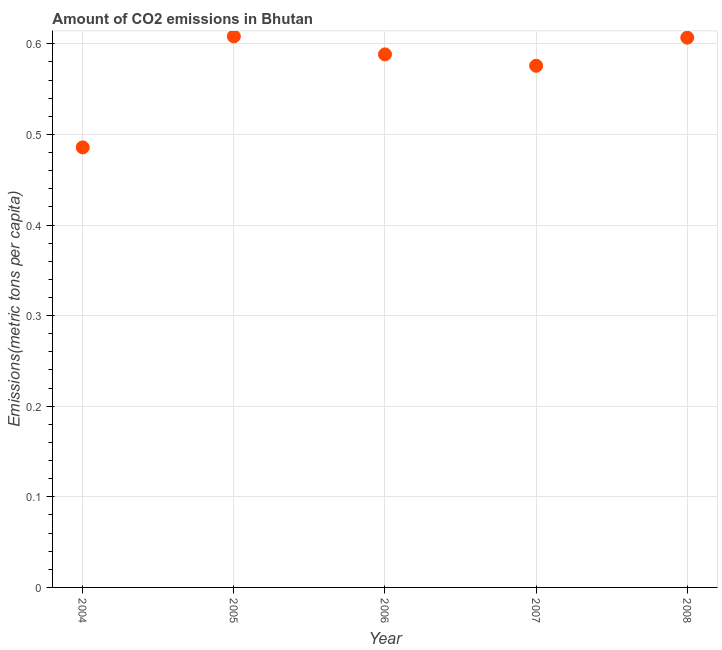What is the amount of co2 emissions in 2005?
Your response must be concise. 0.61. Across all years, what is the maximum amount of co2 emissions?
Your answer should be very brief. 0.61. Across all years, what is the minimum amount of co2 emissions?
Your answer should be compact. 0.49. What is the sum of the amount of co2 emissions?
Provide a short and direct response. 2.86. What is the difference between the amount of co2 emissions in 2004 and 2006?
Offer a very short reply. -0.1. What is the average amount of co2 emissions per year?
Offer a very short reply. 0.57. What is the median amount of co2 emissions?
Make the answer very short. 0.59. In how many years, is the amount of co2 emissions greater than 0.44 metric tons per capita?
Your answer should be compact. 5. What is the ratio of the amount of co2 emissions in 2005 to that in 2006?
Offer a terse response. 1.03. Is the amount of co2 emissions in 2004 less than that in 2008?
Make the answer very short. Yes. What is the difference between the highest and the second highest amount of co2 emissions?
Offer a very short reply. 0. What is the difference between the highest and the lowest amount of co2 emissions?
Offer a terse response. 0.12. In how many years, is the amount of co2 emissions greater than the average amount of co2 emissions taken over all years?
Your response must be concise. 4. Does the amount of co2 emissions monotonically increase over the years?
Provide a succinct answer. No. How many dotlines are there?
Ensure brevity in your answer.  1. What is the difference between two consecutive major ticks on the Y-axis?
Ensure brevity in your answer.  0.1. Are the values on the major ticks of Y-axis written in scientific E-notation?
Make the answer very short. No. Does the graph contain any zero values?
Your answer should be very brief. No. What is the title of the graph?
Ensure brevity in your answer.  Amount of CO2 emissions in Bhutan. What is the label or title of the X-axis?
Ensure brevity in your answer.  Year. What is the label or title of the Y-axis?
Ensure brevity in your answer.  Emissions(metric tons per capita). What is the Emissions(metric tons per capita) in 2004?
Ensure brevity in your answer.  0.49. What is the Emissions(metric tons per capita) in 2005?
Provide a succinct answer. 0.61. What is the Emissions(metric tons per capita) in 2006?
Ensure brevity in your answer.  0.59. What is the Emissions(metric tons per capita) in 2007?
Offer a very short reply. 0.58. What is the Emissions(metric tons per capita) in 2008?
Ensure brevity in your answer.  0.61. What is the difference between the Emissions(metric tons per capita) in 2004 and 2005?
Your answer should be compact. -0.12. What is the difference between the Emissions(metric tons per capita) in 2004 and 2006?
Your answer should be compact. -0.1. What is the difference between the Emissions(metric tons per capita) in 2004 and 2007?
Provide a succinct answer. -0.09. What is the difference between the Emissions(metric tons per capita) in 2004 and 2008?
Give a very brief answer. -0.12. What is the difference between the Emissions(metric tons per capita) in 2005 and 2006?
Your answer should be compact. 0.02. What is the difference between the Emissions(metric tons per capita) in 2005 and 2007?
Give a very brief answer. 0.03. What is the difference between the Emissions(metric tons per capita) in 2005 and 2008?
Your response must be concise. 0. What is the difference between the Emissions(metric tons per capita) in 2006 and 2007?
Ensure brevity in your answer.  0.01. What is the difference between the Emissions(metric tons per capita) in 2006 and 2008?
Your response must be concise. -0.02. What is the difference between the Emissions(metric tons per capita) in 2007 and 2008?
Your answer should be compact. -0.03. What is the ratio of the Emissions(metric tons per capita) in 2004 to that in 2005?
Give a very brief answer. 0.8. What is the ratio of the Emissions(metric tons per capita) in 2004 to that in 2006?
Your response must be concise. 0.83. What is the ratio of the Emissions(metric tons per capita) in 2004 to that in 2007?
Your answer should be very brief. 0.84. What is the ratio of the Emissions(metric tons per capita) in 2005 to that in 2006?
Keep it short and to the point. 1.03. What is the ratio of the Emissions(metric tons per capita) in 2005 to that in 2007?
Offer a very short reply. 1.06. What is the ratio of the Emissions(metric tons per capita) in 2005 to that in 2008?
Ensure brevity in your answer.  1. What is the ratio of the Emissions(metric tons per capita) in 2007 to that in 2008?
Give a very brief answer. 0.95. 